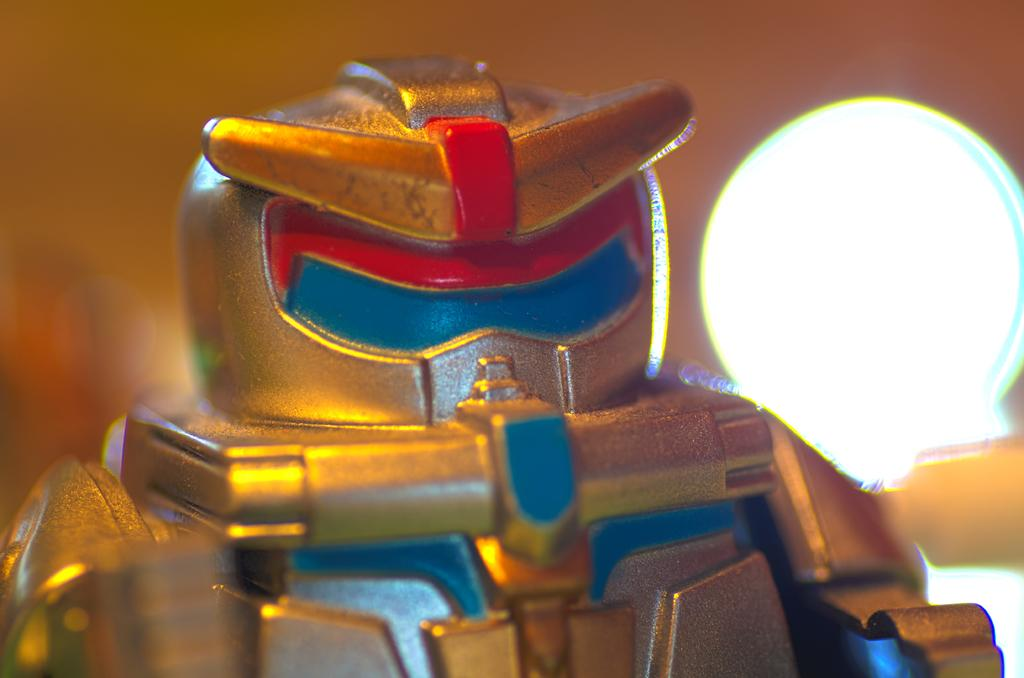What object is the main focus of the image? There is a toy in the image. Can you describe the setting or background of the image? There is a lamp behind the toy in the image. What type of watch is the monkey wearing in the image? There is no monkey or watch present in the image. 